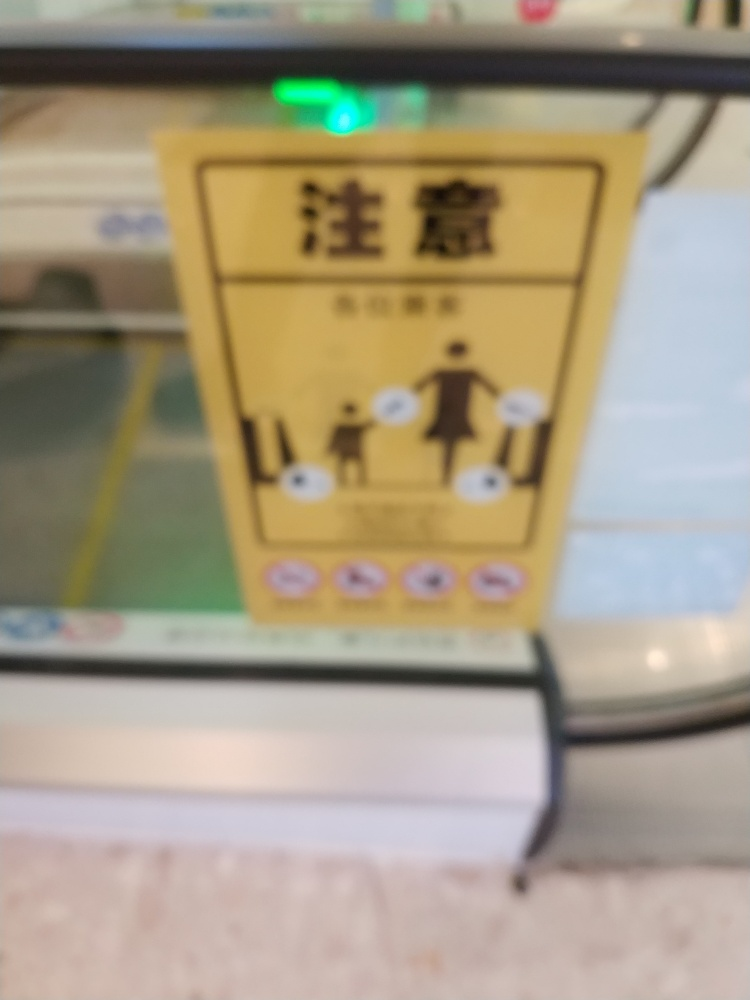Is the image in focus?
A. No
B. Yes
Answer with the option's letter from the given choices directly.
 A. 